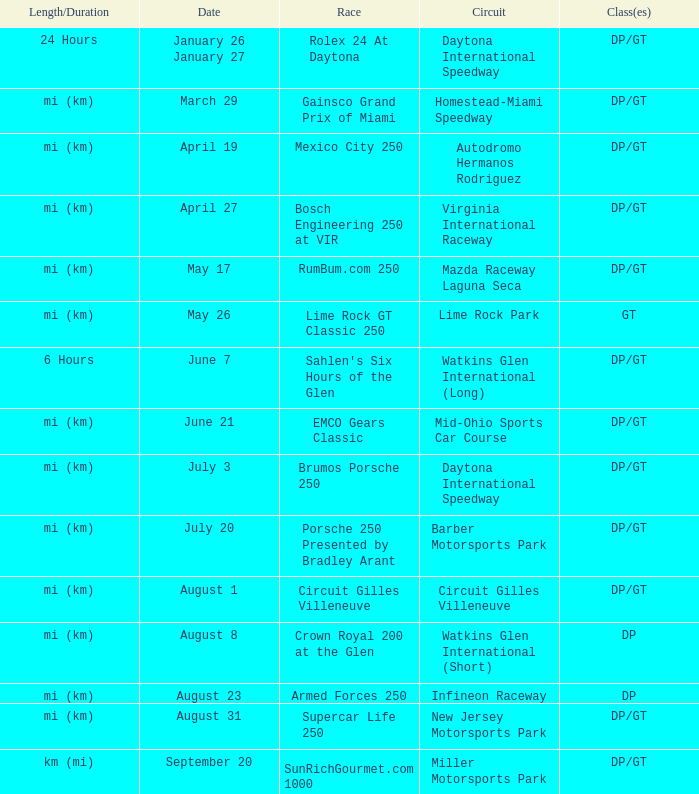What are the classes for the circuit that has the Mazda Raceway Laguna Seca race. DP/GT. 